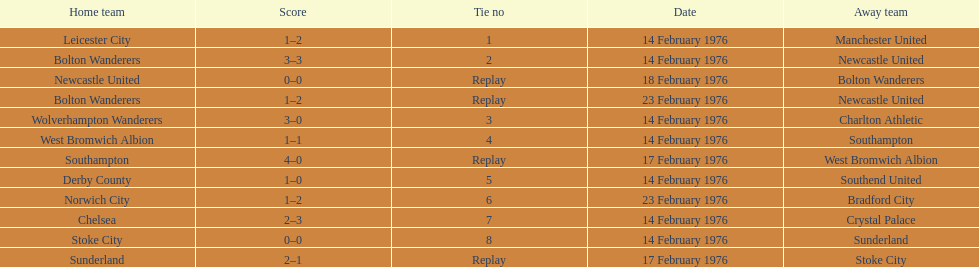Would you mind parsing the complete table? {'header': ['Home team', 'Score', 'Tie no', 'Date', 'Away team'], 'rows': [['Leicester City', '1–2', '1', '14 February 1976', 'Manchester United'], ['Bolton Wanderers', '3–3', '2', '14 February 1976', 'Newcastle United'], ['Newcastle United', '0–0', 'Replay', '18 February 1976', 'Bolton Wanderers'], ['Bolton Wanderers', '1–2', 'Replay', '23 February 1976', 'Newcastle United'], ['Wolverhampton Wanderers', '3–0', '3', '14 February 1976', 'Charlton Athletic'], ['West Bromwich Albion', '1–1', '4', '14 February 1976', 'Southampton'], ['Southampton', '4–0', 'Replay', '17 February 1976', 'West Bromwich Albion'], ['Derby County', '1–0', '5', '14 February 1976', 'Southend United'], ['Norwich City', '1–2', '6', '23 February 1976', 'Bradford City'], ['Chelsea', '2–3', '7', '14 February 1976', 'Crystal Palace'], ['Stoke City', '0–0', '8', '14 February 1976', 'Sunderland'], ['Sunderland', '2–1', 'Replay', '17 February 1976', 'Stoke City']]} What was the goal difference in the game on february 18th? 0. 